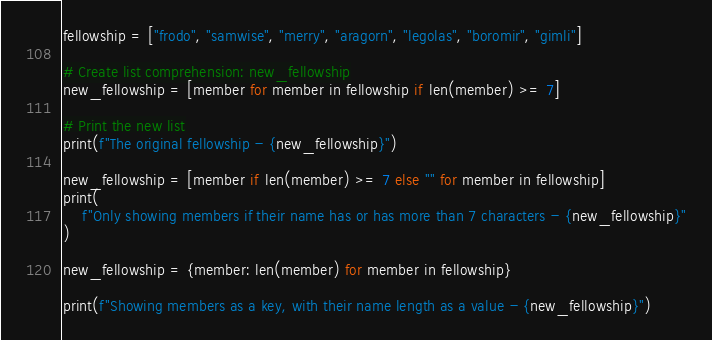<code> <loc_0><loc_0><loc_500><loc_500><_Python_>fellowship = ["frodo", "samwise", "merry", "aragorn", "legolas", "boromir", "gimli"]

# Create list comprehension: new_fellowship
new_fellowship = [member for member in fellowship if len(member) >= 7]

# Print the new list
print(f"The original fellowship - {new_fellowship}")

new_fellowship = [member if len(member) >= 7 else "" for member in fellowship]
print(
    f"Only showing members if their name has or has more than 7 characters - {new_fellowship}"
)

new_fellowship = {member: len(member) for member in fellowship}

print(f"Showing members as a key, with their name length as a value - {new_fellowship}")
</code> 